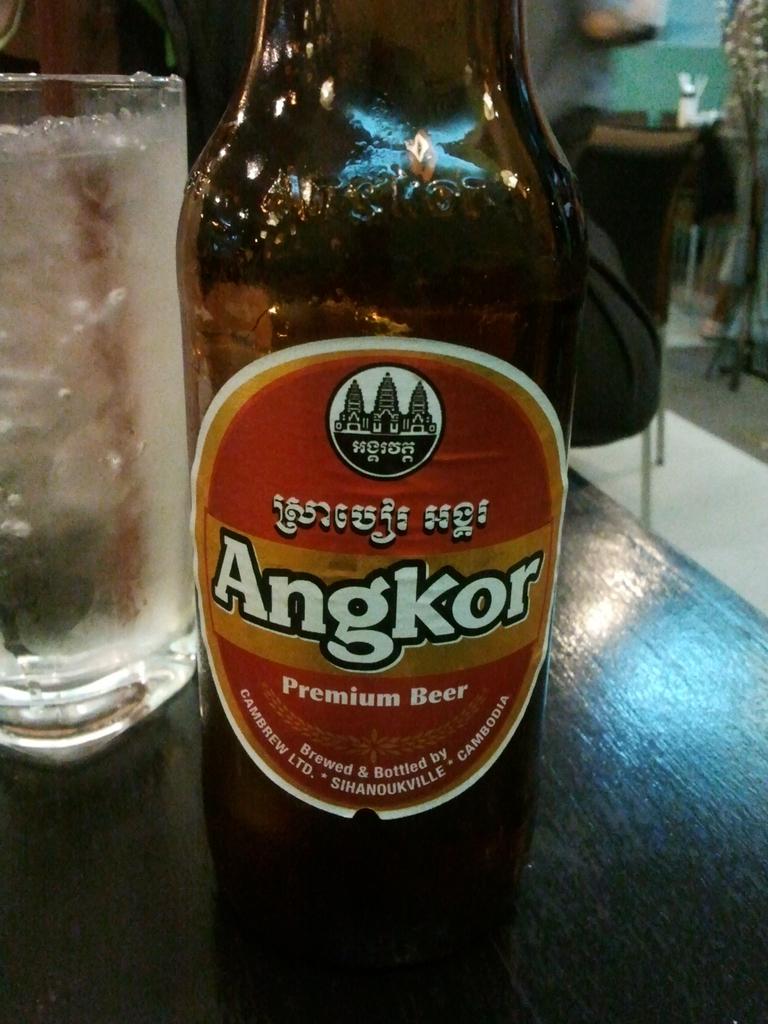What is the name of this drink?
Provide a short and direct response. Angkor. Is this premium beer?
Your answer should be compact. Yes. 